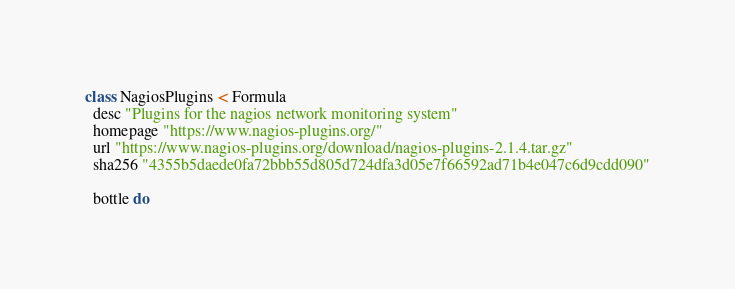Convert code to text. <code><loc_0><loc_0><loc_500><loc_500><_Ruby_>class NagiosPlugins < Formula
  desc "Plugins for the nagios network monitoring system"
  homepage "https://www.nagios-plugins.org/"
  url "https://www.nagios-plugins.org/download/nagios-plugins-2.1.4.tar.gz"
  sha256 "4355b5daede0fa72bbb55d805d724dfa3d05e7f66592ad71b4e047c6d9cdd090"

  bottle do</code> 